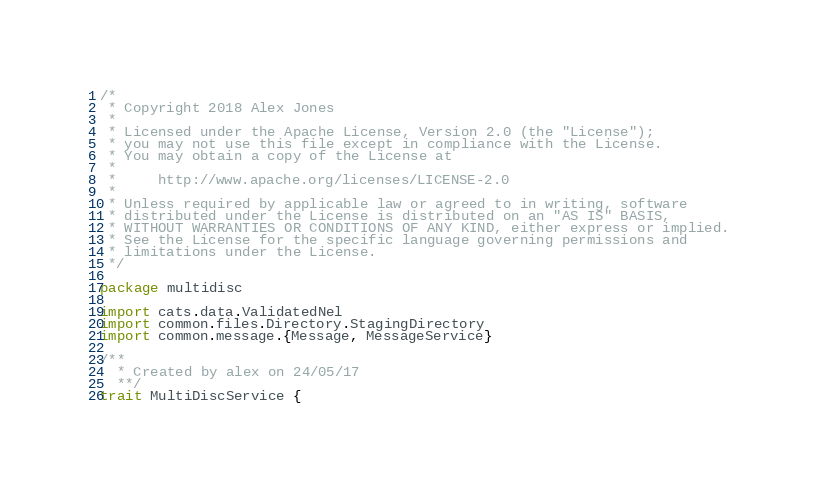<code> <loc_0><loc_0><loc_500><loc_500><_Scala_>/*
 * Copyright 2018 Alex Jones
 *
 * Licensed under the Apache License, Version 2.0 (the "License");
 * you may not use this file except in compliance with the License.
 * You may obtain a copy of the License at
 *
 *     http://www.apache.org/licenses/LICENSE-2.0
 *
 * Unless required by applicable law or agreed to in writing, software
 * distributed under the License is distributed on an "AS IS" BASIS,
 * WITHOUT WARRANTIES OR CONDITIONS OF ANY KIND, either express or implied.
 * See the License for the specific language governing permissions and
 * limitations under the License.
 */

package multidisc

import cats.data.ValidatedNel
import common.files.Directory.StagingDirectory
import common.message.{Message, MessageService}

/**
  * Created by alex on 24/05/17
  **/
trait MultiDiscService {
</code> 